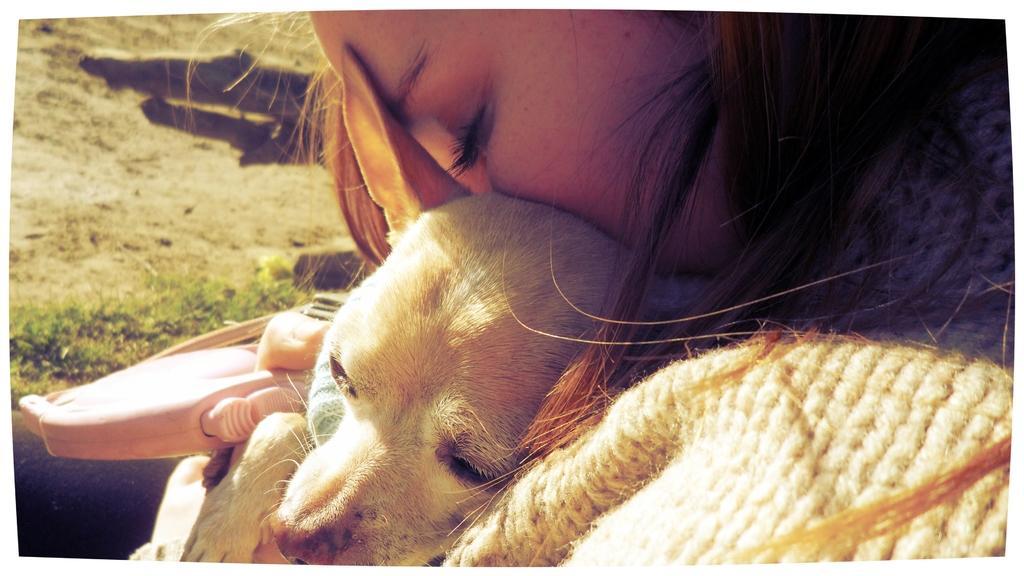How would you summarize this image in a sentence or two? Here we can see a woman and a dog. 